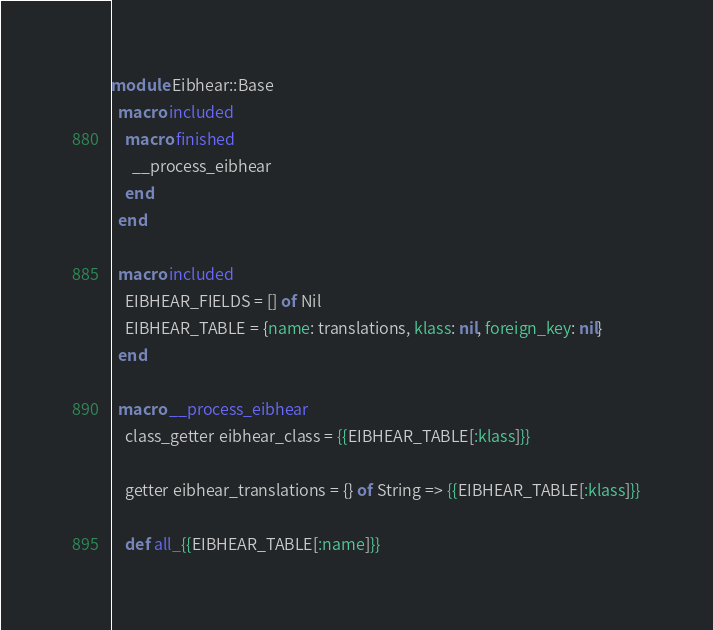<code> <loc_0><loc_0><loc_500><loc_500><_Crystal_>module Eibhear::Base
  macro included
    macro finished
      __process_eibhear
    end
  end

  macro included
    EIBHEAR_FIELDS = [] of Nil
    EIBHEAR_TABLE = {name: translations, klass: nil, foreign_key: nil}
  end

  macro __process_eibhear
    class_getter eibhear_class = {{EIBHEAR_TABLE[:klass]}}

    getter eibhear_translations = {} of String => {{EIBHEAR_TABLE[:klass]}}

    def all_{{EIBHEAR_TABLE[:name]}}</code> 